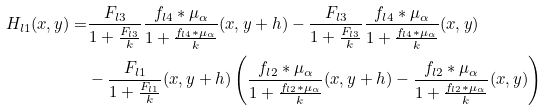Convert formula to latex. <formula><loc_0><loc_0><loc_500><loc_500>H _ { l 1 } ( x , y ) = & \frac { F _ { l 3 } } { 1 + \frac { F _ { l 3 } } { k } } \frac { f _ { l 4 } \ast \mu _ { \alpha } } { 1 + \frac { f _ { l 4 } \ast \mu _ { \alpha } } { k } } ( x , y + h ) - \frac { F _ { l 3 } } { 1 + \frac { F _ { l 3 } } { k } } \frac { f _ { l 4 } \ast \mu _ { \alpha } } { 1 + \frac { f _ { l 4 } \ast \mu _ { \alpha } } { k } } ( x , y ) \\ & - \frac { F _ { l 1 } } { 1 + \frac { F _ { l 1 } } { k } } ( x , y + h ) \left ( \frac { f _ { l 2 } \ast \mu _ { \alpha } } { 1 + \frac { f _ { l 2 } \ast \mu _ { \alpha } } { k } } ( x , y + h ) - \frac { f _ { l 2 } \ast \mu _ { \alpha } } { 1 + \frac { f _ { l 2 } \ast \mu _ { \alpha } } { k } } ( x , y ) \right )</formula> 